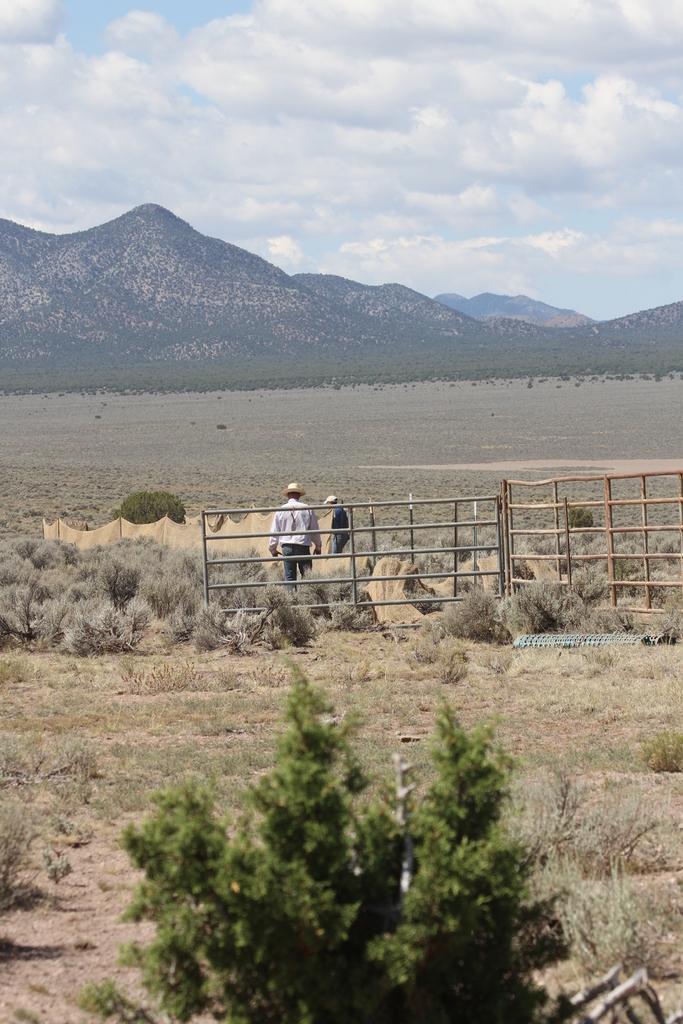How would you summarize this image in a sentence or two? In this image I can see an open ground and on it I can see grass and I can see few people are standing, I can see both of them are wearing hats. In the background I can see mountains, clouds and sky. 